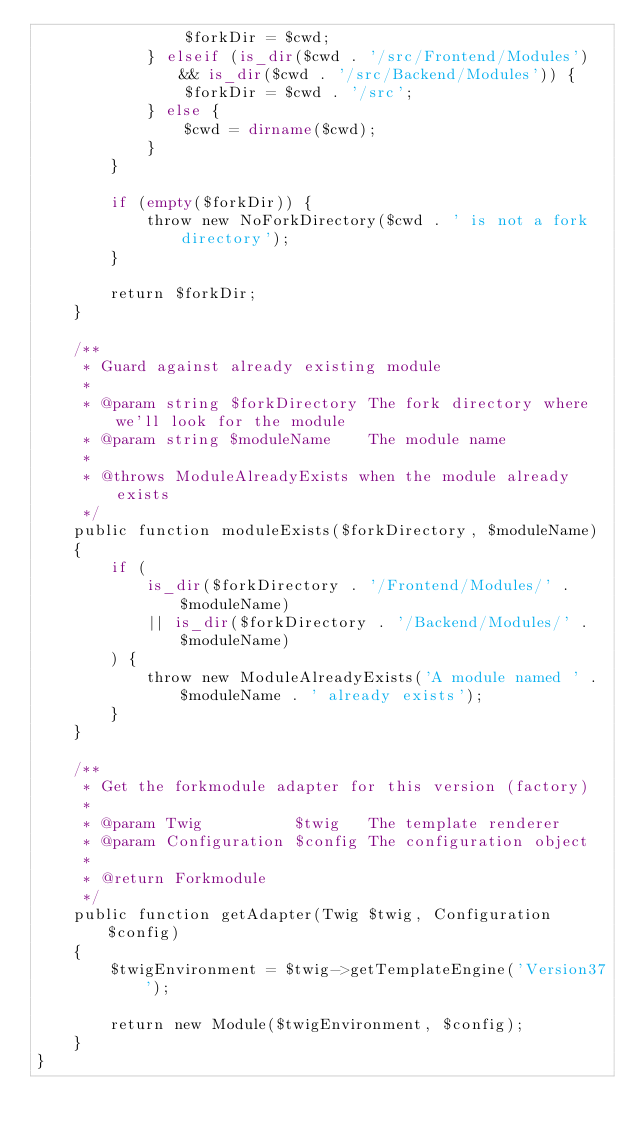<code> <loc_0><loc_0><loc_500><loc_500><_PHP_>                $forkDir = $cwd;
            } elseif (is_dir($cwd . '/src/Frontend/Modules') && is_dir($cwd . '/src/Backend/Modules')) {
                $forkDir = $cwd . '/src';
            } else {
                $cwd = dirname($cwd);
            }
        }

        if (empty($forkDir)) {
            throw new NoForkDirectory($cwd . ' is not a fork directory');
        }

        return $forkDir;
    }

    /**
     * Guard against already existing module
     *
     * @param string $forkDirectory The fork directory where we'll look for the module
     * @param string $moduleName    The module name
     *
     * @throws ModuleAlreadyExists when the module already exists
     */
    public function moduleExists($forkDirectory, $moduleName)
    {
        if (
            is_dir($forkDirectory . '/Frontend/Modules/' . $moduleName)
            || is_dir($forkDirectory . '/Backend/Modules/' . $moduleName)
        ) {
            throw new ModuleAlreadyExists('A module named ' . $moduleName . ' already exists');
        }
    }

    /**
     * Get the forkmodule adapter for this version (factory)
     *
     * @param Twig          $twig   The template renderer
     * @param Configuration $config The configuration object
     *
     * @return Forkmodule
     */
    public function getAdapter(Twig $twig, Configuration $config)
    {
        $twigEnvironment = $twig->getTemplateEngine('Version37');

        return new Module($twigEnvironment, $config);
    }
}
</code> 